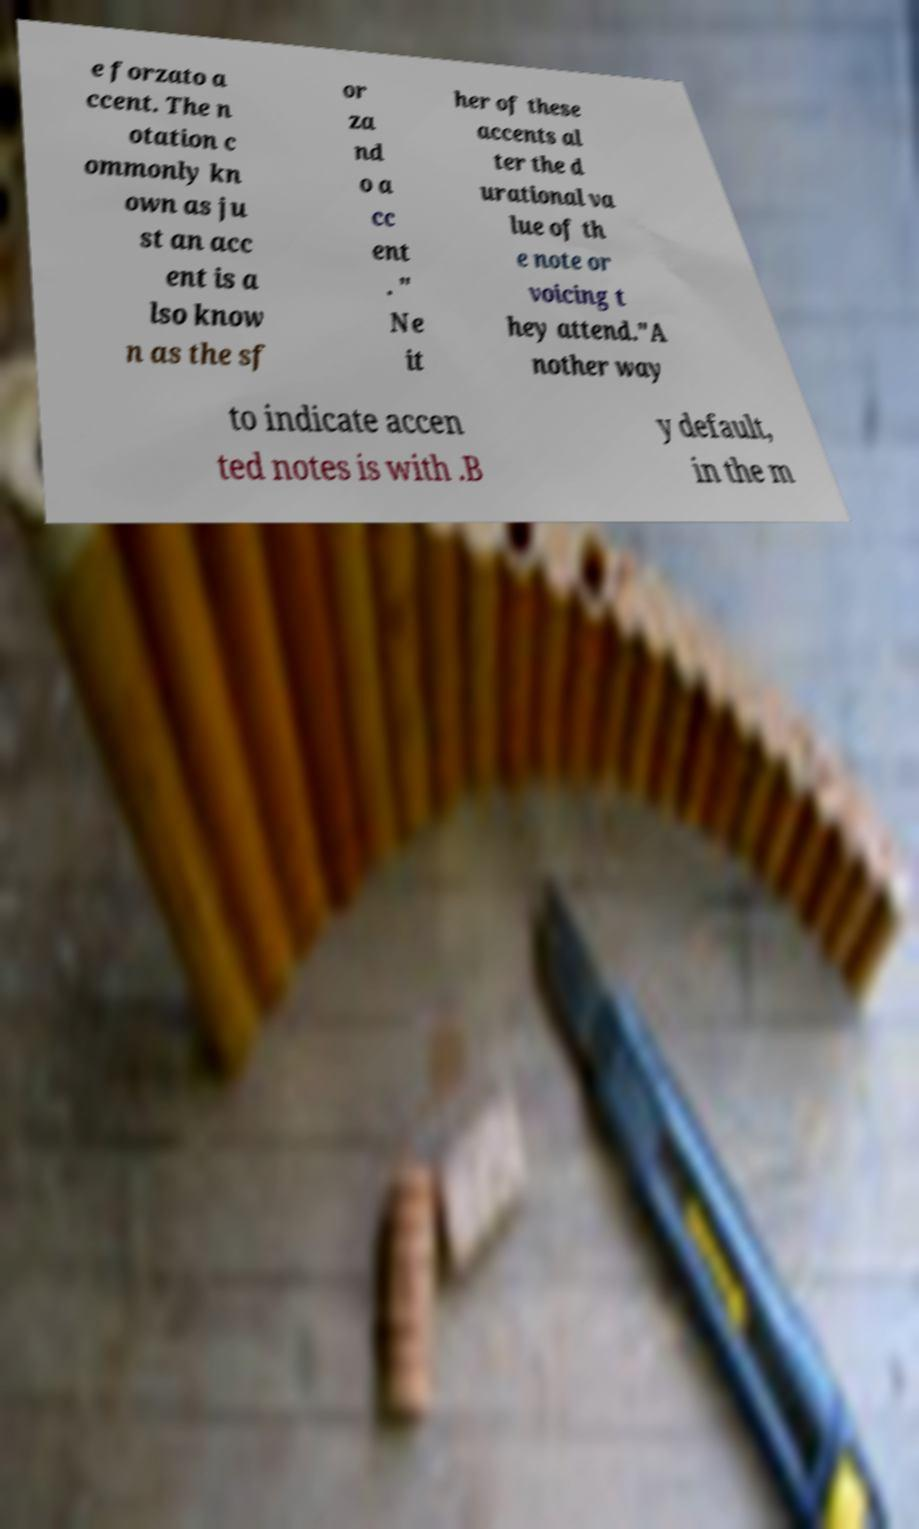There's text embedded in this image that I need extracted. Can you transcribe it verbatim? e forzato a ccent. The n otation c ommonly kn own as ju st an acc ent is a lso know n as the sf or za nd o a cc ent . " Ne it her of these accents al ter the d urational va lue of th e note or voicing t hey attend."A nother way to indicate accen ted notes is with .B y default, in the m 